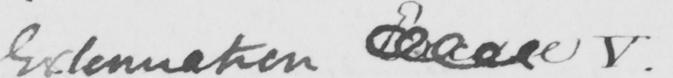What is written in this line of handwriting? Extenuation Excuse V . 